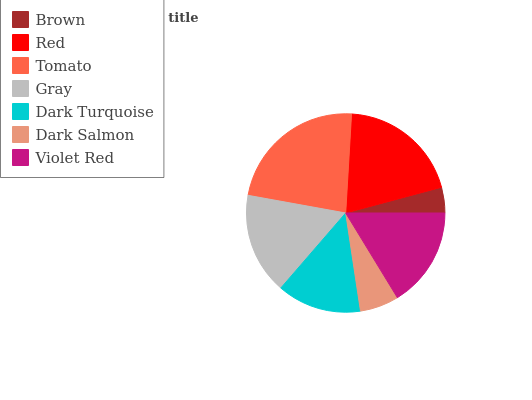Is Brown the minimum?
Answer yes or no. Yes. Is Tomato the maximum?
Answer yes or no. Yes. Is Red the minimum?
Answer yes or no. No. Is Red the maximum?
Answer yes or no. No. Is Red greater than Brown?
Answer yes or no. Yes. Is Brown less than Red?
Answer yes or no. Yes. Is Brown greater than Red?
Answer yes or no. No. Is Red less than Brown?
Answer yes or no. No. Is Violet Red the high median?
Answer yes or no. Yes. Is Violet Red the low median?
Answer yes or no. Yes. Is Brown the high median?
Answer yes or no. No. Is Gray the low median?
Answer yes or no. No. 